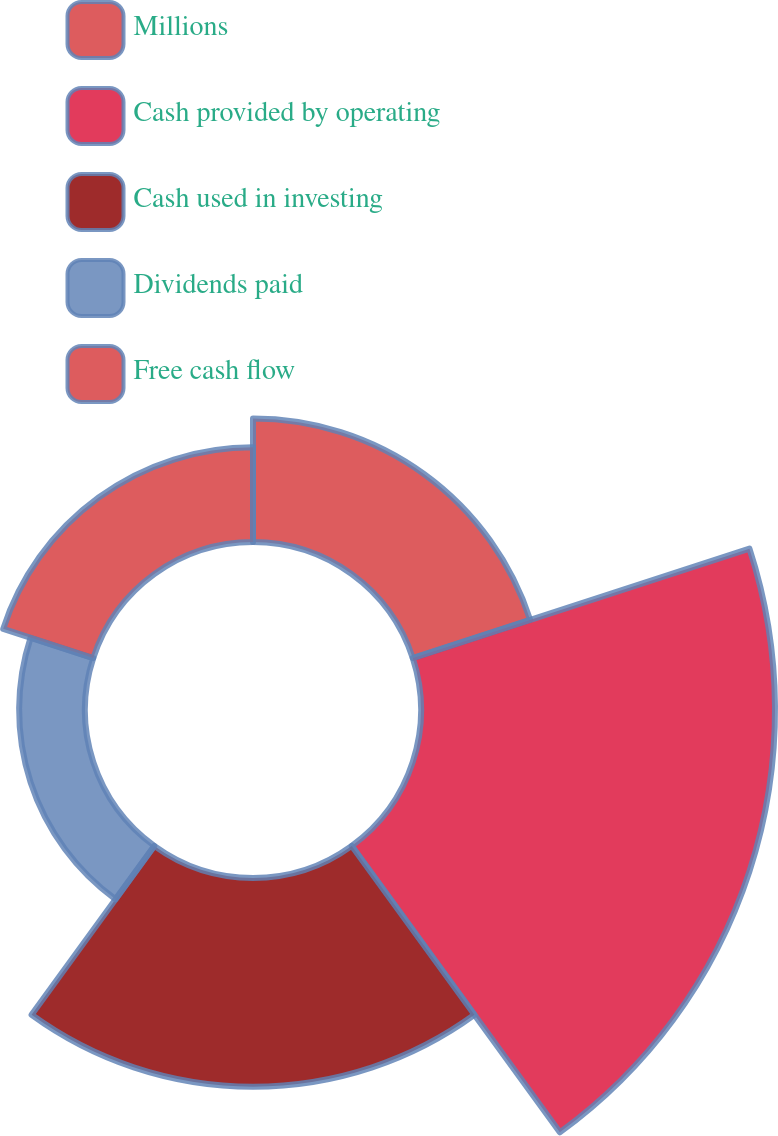Convert chart. <chart><loc_0><loc_0><loc_500><loc_500><pie_chart><fcel>Millions<fcel>Cash provided by operating<fcel>Cash used in investing<fcel>Dividends paid<fcel>Free cash flow<nl><fcel>14.58%<fcel>41.81%<fcel>24.65%<fcel>7.78%<fcel>11.18%<nl></chart> 